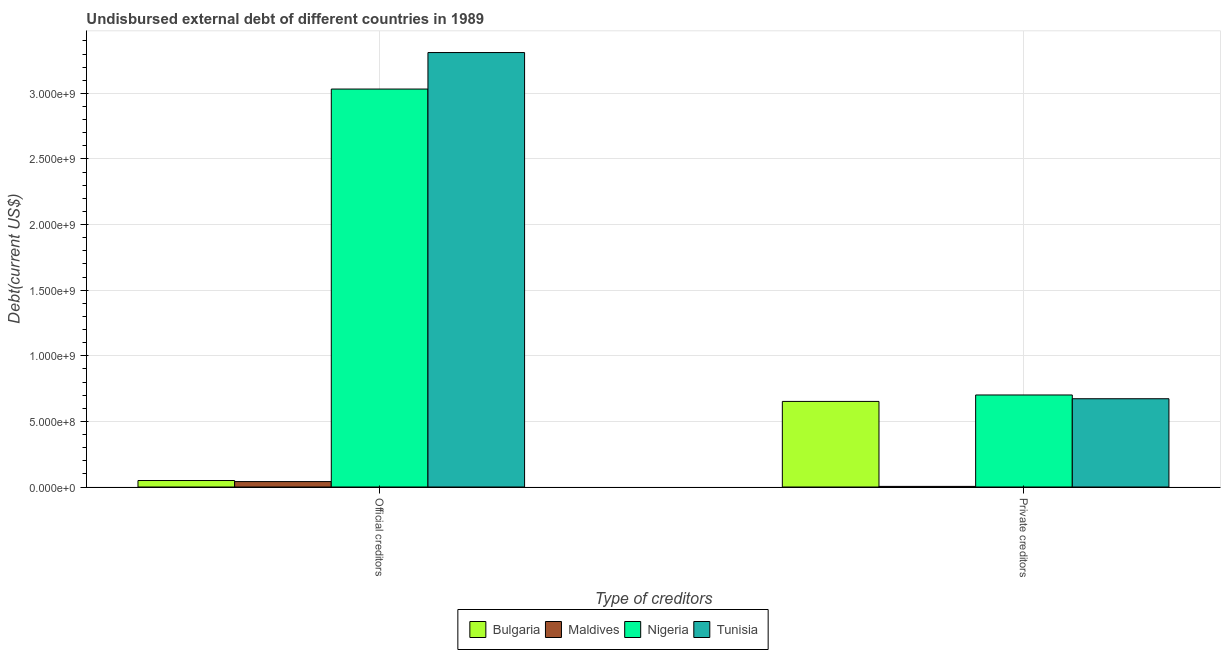Are the number of bars on each tick of the X-axis equal?
Keep it short and to the point. Yes. What is the label of the 1st group of bars from the left?
Provide a succinct answer. Official creditors. What is the undisbursed external debt of private creditors in Maldives?
Offer a terse response. 4.68e+06. Across all countries, what is the maximum undisbursed external debt of private creditors?
Make the answer very short. 7.01e+08. Across all countries, what is the minimum undisbursed external debt of official creditors?
Keep it short and to the point. 4.13e+07. In which country was the undisbursed external debt of official creditors maximum?
Make the answer very short. Tunisia. In which country was the undisbursed external debt of official creditors minimum?
Provide a succinct answer. Maldives. What is the total undisbursed external debt of private creditors in the graph?
Your response must be concise. 2.03e+09. What is the difference between the undisbursed external debt of private creditors in Nigeria and that in Bulgaria?
Provide a succinct answer. 4.91e+07. What is the difference between the undisbursed external debt of official creditors in Nigeria and the undisbursed external debt of private creditors in Tunisia?
Provide a succinct answer. 2.36e+09. What is the average undisbursed external debt of official creditors per country?
Ensure brevity in your answer.  1.61e+09. What is the difference between the undisbursed external debt of official creditors and undisbursed external debt of private creditors in Nigeria?
Your answer should be very brief. 2.33e+09. What is the ratio of the undisbursed external debt of official creditors in Bulgaria to that in Tunisia?
Your answer should be very brief. 0.01. Is the undisbursed external debt of official creditors in Maldives less than that in Tunisia?
Provide a short and direct response. Yes. What does the 3rd bar from the left in Private creditors represents?
Provide a short and direct response. Nigeria. What does the 3rd bar from the right in Private creditors represents?
Make the answer very short. Maldives. Does the graph contain any zero values?
Ensure brevity in your answer.  No. Where does the legend appear in the graph?
Provide a succinct answer. Bottom center. What is the title of the graph?
Your answer should be compact. Undisbursed external debt of different countries in 1989. What is the label or title of the X-axis?
Give a very brief answer. Type of creditors. What is the label or title of the Y-axis?
Provide a succinct answer. Debt(current US$). What is the Debt(current US$) of Bulgaria in Official creditors?
Offer a terse response. 4.94e+07. What is the Debt(current US$) in Maldives in Official creditors?
Your answer should be very brief. 4.13e+07. What is the Debt(current US$) in Nigeria in Official creditors?
Your response must be concise. 3.03e+09. What is the Debt(current US$) of Tunisia in Official creditors?
Give a very brief answer. 3.31e+09. What is the Debt(current US$) of Bulgaria in Private creditors?
Your answer should be compact. 6.52e+08. What is the Debt(current US$) of Maldives in Private creditors?
Give a very brief answer. 4.68e+06. What is the Debt(current US$) in Nigeria in Private creditors?
Provide a short and direct response. 7.01e+08. What is the Debt(current US$) in Tunisia in Private creditors?
Your answer should be very brief. 6.73e+08. Across all Type of creditors, what is the maximum Debt(current US$) of Bulgaria?
Keep it short and to the point. 6.52e+08. Across all Type of creditors, what is the maximum Debt(current US$) in Maldives?
Provide a short and direct response. 4.13e+07. Across all Type of creditors, what is the maximum Debt(current US$) of Nigeria?
Your response must be concise. 3.03e+09. Across all Type of creditors, what is the maximum Debt(current US$) in Tunisia?
Offer a very short reply. 3.31e+09. Across all Type of creditors, what is the minimum Debt(current US$) in Bulgaria?
Give a very brief answer. 4.94e+07. Across all Type of creditors, what is the minimum Debt(current US$) of Maldives?
Your response must be concise. 4.68e+06. Across all Type of creditors, what is the minimum Debt(current US$) in Nigeria?
Give a very brief answer. 7.01e+08. Across all Type of creditors, what is the minimum Debt(current US$) in Tunisia?
Your answer should be very brief. 6.73e+08. What is the total Debt(current US$) of Bulgaria in the graph?
Provide a short and direct response. 7.02e+08. What is the total Debt(current US$) in Maldives in the graph?
Offer a very short reply. 4.60e+07. What is the total Debt(current US$) of Nigeria in the graph?
Provide a short and direct response. 3.73e+09. What is the total Debt(current US$) in Tunisia in the graph?
Your answer should be compact. 3.98e+09. What is the difference between the Debt(current US$) in Bulgaria in Official creditors and that in Private creditors?
Your answer should be compact. -6.03e+08. What is the difference between the Debt(current US$) in Maldives in Official creditors and that in Private creditors?
Provide a succinct answer. 3.66e+07. What is the difference between the Debt(current US$) in Nigeria in Official creditors and that in Private creditors?
Provide a short and direct response. 2.33e+09. What is the difference between the Debt(current US$) of Tunisia in Official creditors and that in Private creditors?
Your answer should be very brief. 2.64e+09. What is the difference between the Debt(current US$) in Bulgaria in Official creditors and the Debt(current US$) in Maldives in Private creditors?
Make the answer very short. 4.47e+07. What is the difference between the Debt(current US$) in Bulgaria in Official creditors and the Debt(current US$) in Nigeria in Private creditors?
Give a very brief answer. -6.52e+08. What is the difference between the Debt(current US$) of Bulgaria in Official creditors and the Debt(current US$) of Tunisia in Private creditors?
Make the answer very short. -6.23e+08. What is the difference between the Debt(current US$) in Maldives in Official creditors and the Debt(current US$) in Nigeria in Private creditors?
Your response must be concise. -6.60e+08. What is the difference between the Debt(current US$) of Maldives in Official creditors and the Debt(current US$) of Tunisia in Private creditors?
Give a very brief answer. -6.31e+08. What is the difference between the Debt(current US$) of Nigeria in Official creditors and the Debt(current US$) of Tunisia in Private creditors?
Keep it short and to the point. 2.36e+09. What is the average Debt(current US$) of Bulgaria per Type of creditors?
Your answer should be compact. 3.51e+08. What is the average Debt(current US$) in Maldives per Type of creditors?
Offer a very short reply. 2.30e+07. What is the average Debt(current US$) in Nigeria per Type of creditors?
Offer a very short reply. 1.87e+09. What is the average Debt(current US$) of Tunisia per Type of creditors?
Your response must be concise. 1.99e+09. What is the difference between the Debt(current US$) in Bulgaria and Debt(current US$) in Maldives in Official creditors?
Ensure brevity in your answer.  8.07e+06. What is the difference between the Debt(current US$) of Bulgaria and Debt(current US$) of Nigeria in Official creditors?
Your response must be concise. -2.98e+09. What is the difference between the Debt(current US$) of Bulgaria and Debt(current US$) of Tunisia in Official creditors?
Keep it short and to the point. -3.26e+09. What is the difference between the Debt(current US$) in Maldives and Debt(current US$) in Nigeria in Official creditors?
Keep it short and to the point. -2.99e+09. What is the difference between the Debt(current US$) of Maldives and Debt(current US$) of Tunisia in Official creditors?
Your answer should be compact. -3.27e+09. What is the difference between the Debt(current US$) of Nigeria and Debt(current US$) of Tunisia in Official creditors?
Your answer should be very brief. -2.78e+08. What is the difference between the Debt(current US$) in Bulgaria and Debt(current US$) in Maldives in Private creditors?
Keep it short and to the point. 6.48e+08. What is the difference between the Debt(current US$) in Bulgaria and Debt(current US$) in Nigeria in Private creditors?
Your answer should be compact. -4.91e+07. What is the difference between the Debt(current US$) in Bulgaria and Debt(current US$) in Tunisia in Private creditors?
Offer a terse response. -2.04e+07. What is the difference between the Debt(current US$) in Maldives and Debt(current US$) in Nigeria in Private creditors?
Offer a very short reply. -6.97e+08. What is the difference between the Debt(current US$) of Maldives and Debt(current US$) of Tunisia in Private creditors?
Make the answer very short. -6.68e+08. What is the difference between the Debt(current US$) in Nigeria and Debt(current US$) in Tunisia in Private creditors?
Keep it short and to the point. 2.86e+07. What is the ratio of the Debt(current US$) in Bulgaria in Official creditors to that in Private creditors?
Your response must be concise. 0.08. What is the ratio of the Debt(current US$) of Maldives in Official creditors to that in Private creditors?
Make the answer very short. 8.82. What is the ratio of the Debt(current US$) of Nigeria in Official creditors to that in Private creditors?
Give a very brief answer. 4.32. What is the ratio of the Debt(current US$) of Tunisia in Official creditors to that in Private creditors?
Your response must be concise. 4.92. What is the difference between the highest and the second highest Debt(current US$) of Bulgaria?
Provide a short and direct response. 6.03e+08. What is the difference between the highest and the second highest Debt(current US$) of Maldives?
Offer a terse response. 3.66e+07. What is the difference between the highest and the second highest Debt(current US$) in Nigeria?
Offer a very short reply. 2.33e+09. What is the difference between the highest and the second highest Debt(current US$) of Tunisia?
Make the answer very short. 2.64e+09. What is the difference between the highest and the lowest Debt(current US$) of Bulgaria?
Your answer should be compact. 6.03e+08. What is the difference between the highest and the lowest Debt(current US$) in Maldives?
Provide a short and direct response. 3.66e+07. What is the difference between the highest and the lowest Debt(current US$) in Nigeria?
Provide a short and direct response. 2.33e+09. What is the difference between the highest and the lowest Debt(current US$) in Tunisia?
Your answer should be compact. 2.64e+09. 